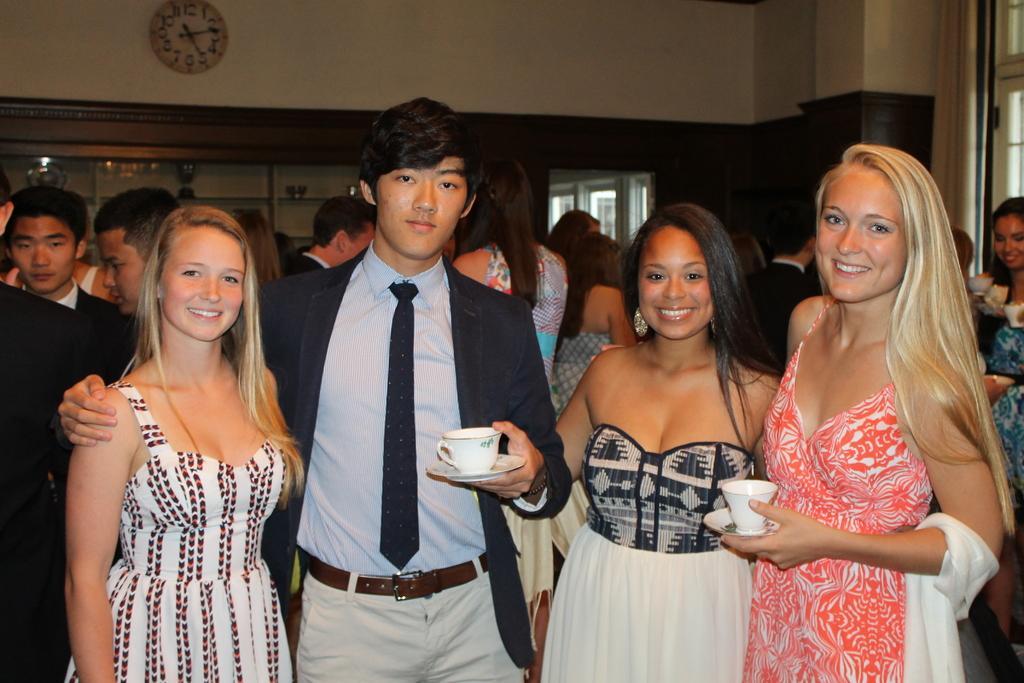Please provide a concise description of this image. In this picture we can see four people standing and smiling. Two people are holding cups and saucers. In the background we can see a group of people, walls, windows, clock and some objects. 